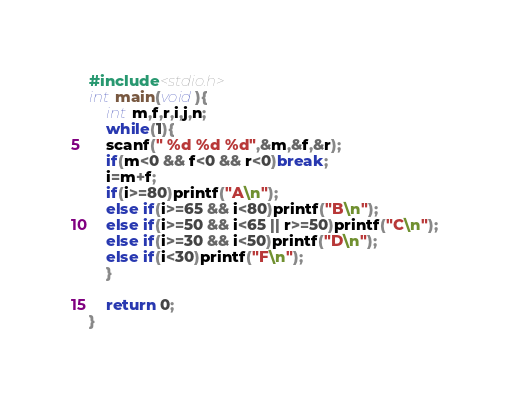<code> <loc_0><loc_0><loc_500><loc_500><_C_>#include<stdio.h>
int main(void){
    int m,f,r,i,j,n;
    while(1){
    scanf(" %d %d %d",&m,&f,&r);
    if(m<0 && f<0 && r<0)break;
    i=m+f;
    if(i>=80)printf("A\n");
    else if(i>=65 && i<80)printf("B\n");
    else if(i>=50 && i<65 || r>=50)printf("C\n");
    else if(i>=30 && i<50)printf("D\n");
    else if(i<30)printf("F\n");
    }

    return 0;
}</code> 